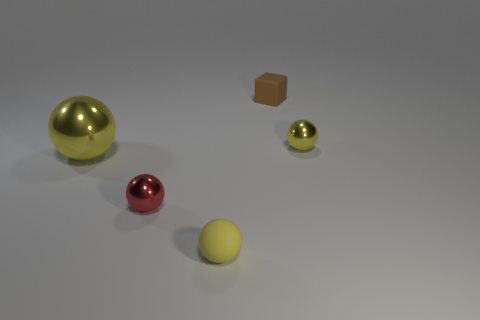Subtract all yellow balls. How many were subtracted if there are1yellow balls left? 2 Subtract all purple cylinders. How many yellow spheres are left? 3 Add 5 big shiny things. How many objects exist? 10 Subtract all cubes. How many objects are left? 4 Subtract all yellow metal things. Subtract all large yellow metallic things. How many objects are left? 2 Add 4 yellow rubber objects. How many yellow rubber objects are left? 5 Add 4 large yellow blocks. How many large yellow blocks exist? 4 Subtract 0 green balls. How many objects are left? 5 